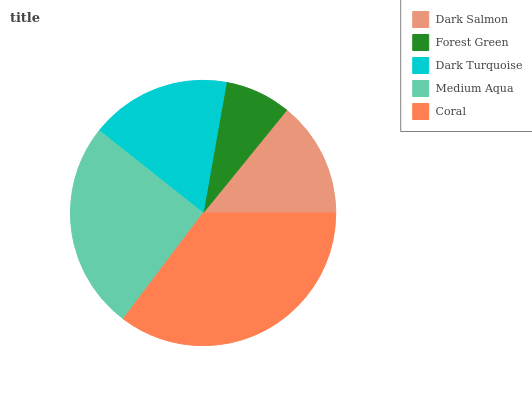Is Forest Green the minimum?
Answer yes or no. Yes. Is Coral the maximum?
Answer yes or no. Yes. Is Dark Turquoise the minimum?
Answer yes or no. No. Is Dark Turquoise the maximum?
Answer yes or no. No. Is Dark Turquoise greater than Forest Green?
Answer yes or no. Yes. Is Forest Green less than Dark Turquoise?
Answer yes or no. Yes. Is Forest Green greater than Dark Turquoise?
Answer yes or no. No. Is Dark Turquoise less than Forest Green?
Answer yes or no. No. Is Dark Turquoise the high median?
Answer yes or no. Yes. Is Dark Turquoise the low median?
Answer yes or no. Yes. Is Dark Salmon the high median?
Answer yes or no. No. Is Medium Aqua the low median?
Answer yes or no. No. 